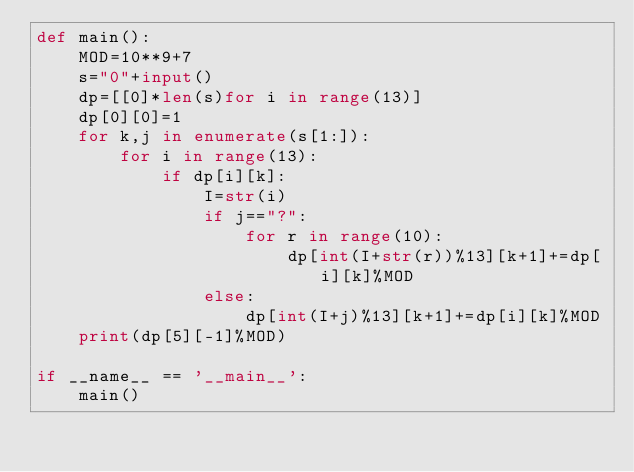Convert code to text. <code><loc_0><loc_0><loc_500><loc_500><_Python_>def main():
    MOD=10**9+7
    s="0"+input()
    dp=[[0]*len(s)for i in range(13)]
    dp[0][0]=1
    for k,j in enumerate(s[1:]):
        for i in range(13):
            if dp[i][k]:
                I=str(i)
                if j=="?":
                    for r in range(10):
                        dp[int(I+str(r))%13][k+1]+=dp[i][k]%MOD
                else:
                    dp[int(I+j)%13][k+1]+=dp[i][k]%MOD
    print(dp[5][-1]%MOD)
    
if __name__ == '__main__':
    main()</code> 